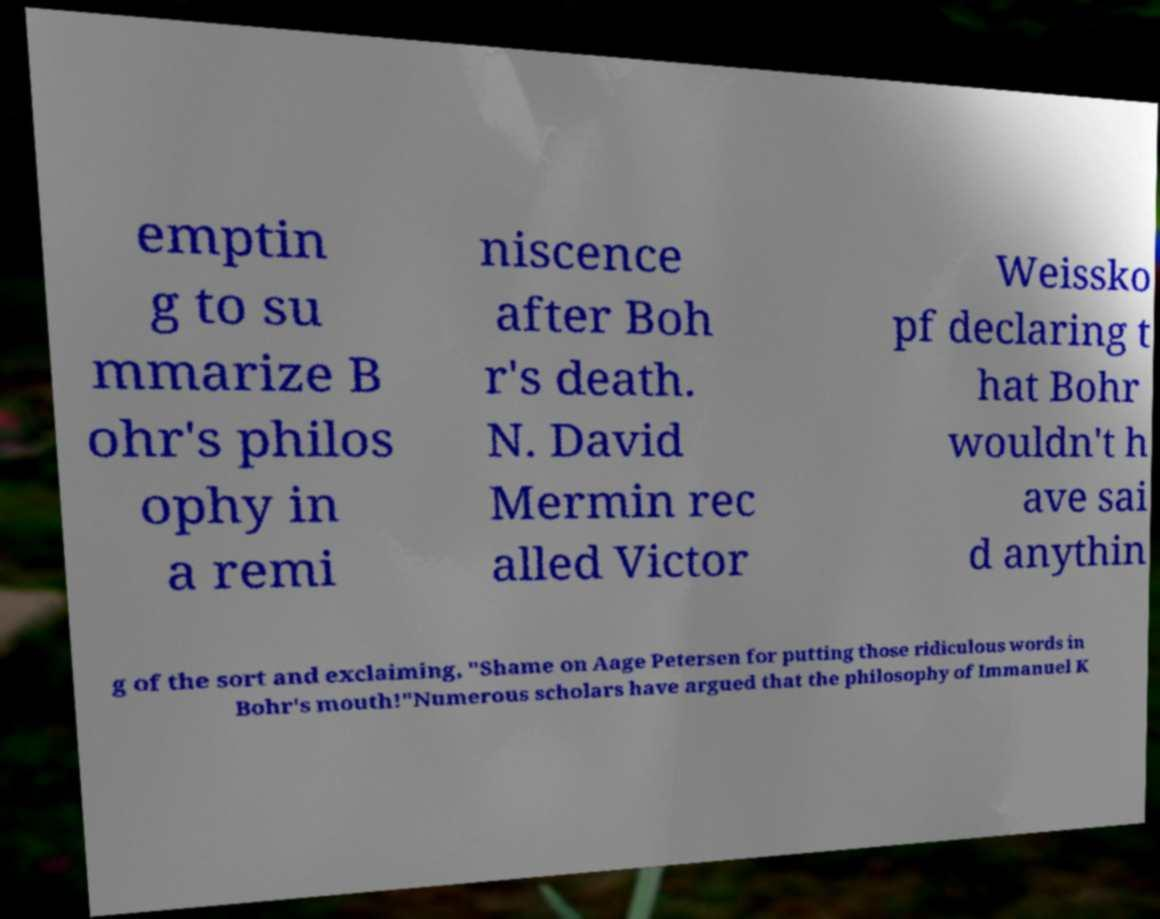Could you assist in decoding the text presented in this image and type it out clearly? emptin g to su mmarize B ohr's philos ophy in a remi niscence after Boh r's death. N. David Mermin rec alled Victor Weissko pf declaring t hat Bohr wouldn't h ave sai d anythin g of the sort and exclaiming, "Shame on Aage Petersen for putting those ridiculous words in Bohr's mouth!"Numerous scholars have argued that the philosophy of Immanuel K 